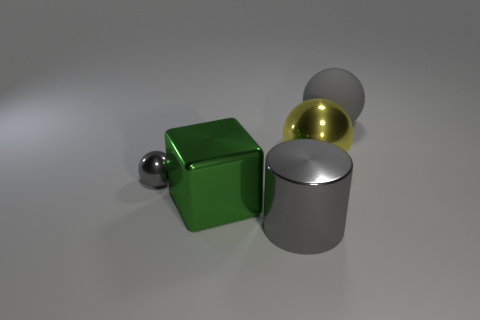Subtract all big shiny balls. How many balls are left? 2 Subtract all yellow balls. How many balls are left? 2 Add 2 tiny green rubber things. How many objects exist? 7 Subtract all spheres. How many objects are left? 2 Subtract 1 cylinders. How many cylinders are left? 0 Subtract all purple blocks. How many cyan cylinders are left? 0 Subtract all yellow rubber cylinders. Subtract all tiny gray metallic balls. How many objects are left? 4 Add 3 big metal things. How many big metal things are left? 6 Add 2 yellow shiny balls. How many yellow shiny balls exist? 3 Subtract 0 cyan cubes. How many objects are left? 5 